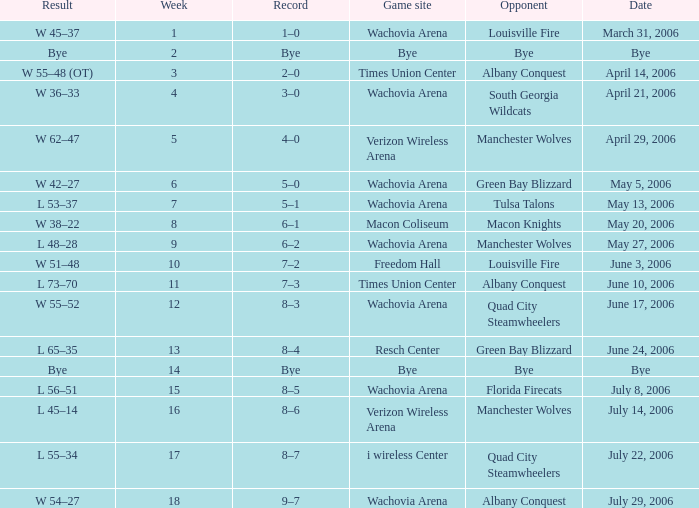What team was the opponent in a week earlier than 17 on June 17, 2006? Quad City Steamwheelers. 